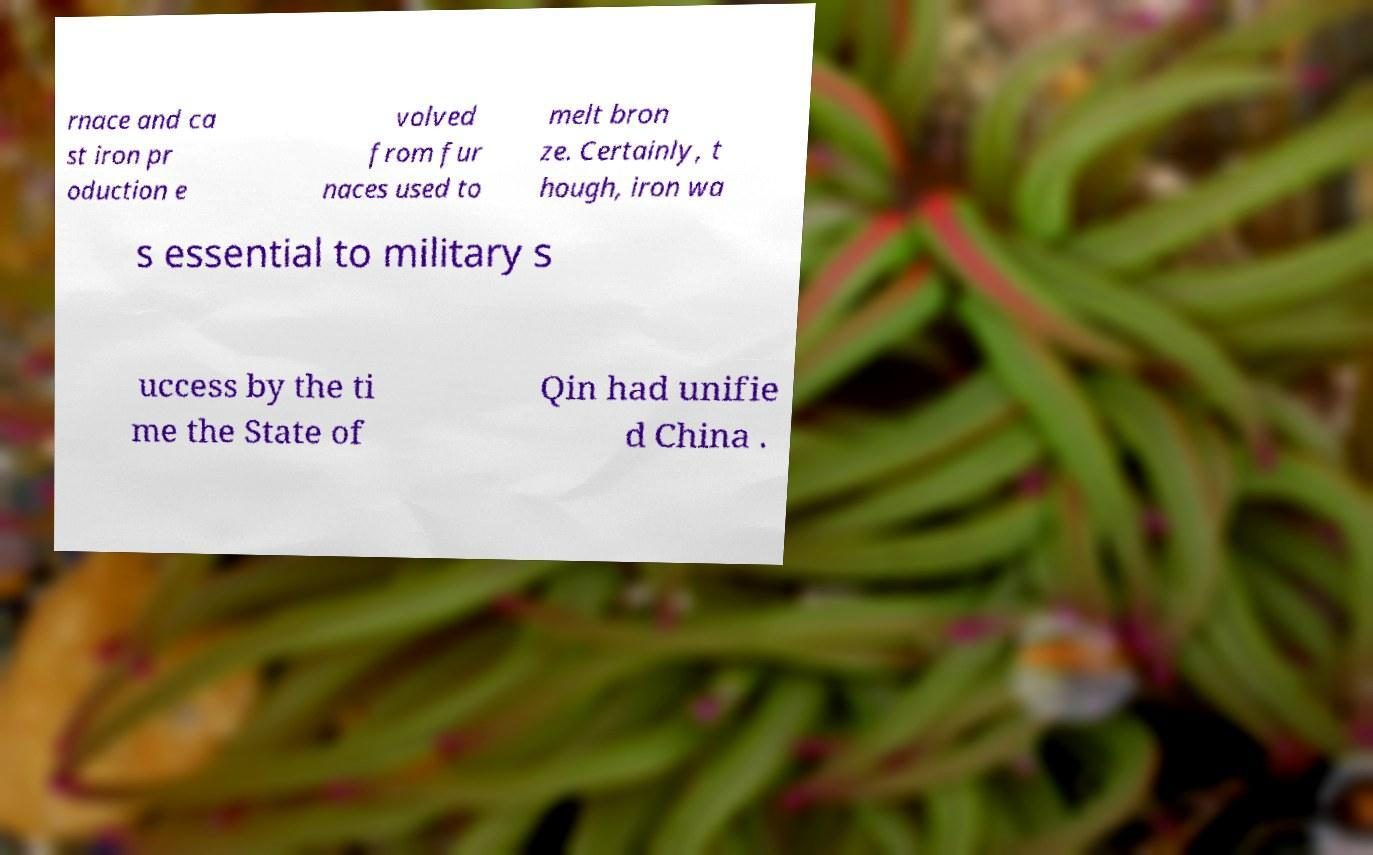Can you accurately transcribe the text from the provided image for me? rnace and ca st iron pr oduction e volved from fur naces used to melt bron ze. Certainly, t hough, iron wa s essential to military s uccess by the ti me the State of Qin had unifie d China . 